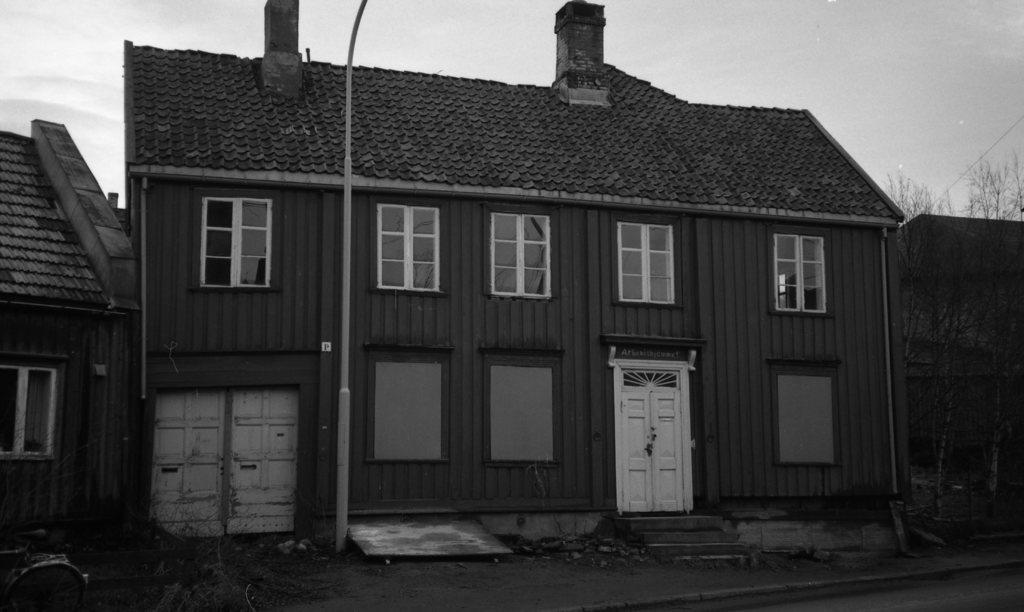Please provide a concise description of this image. It is the black and white image in which we can see there is a building in the middle. At the bottom there are doors. At the top there are windows. On the right side there are trees. In the middle there is a pole in front of the house. On the left side bottom there is a cycle. 